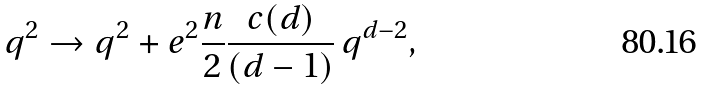Convert formula to latex. <formula><loc_0><loc_0><loc_500><loc_500>q ^ { 2 } \to q ^ { 2 } + e ^ { 2 } \frac { n } { 2 } \frac { c ( d ) } { ( d - 1 ) } \, q ^ { d - 2 } ,</formula> 